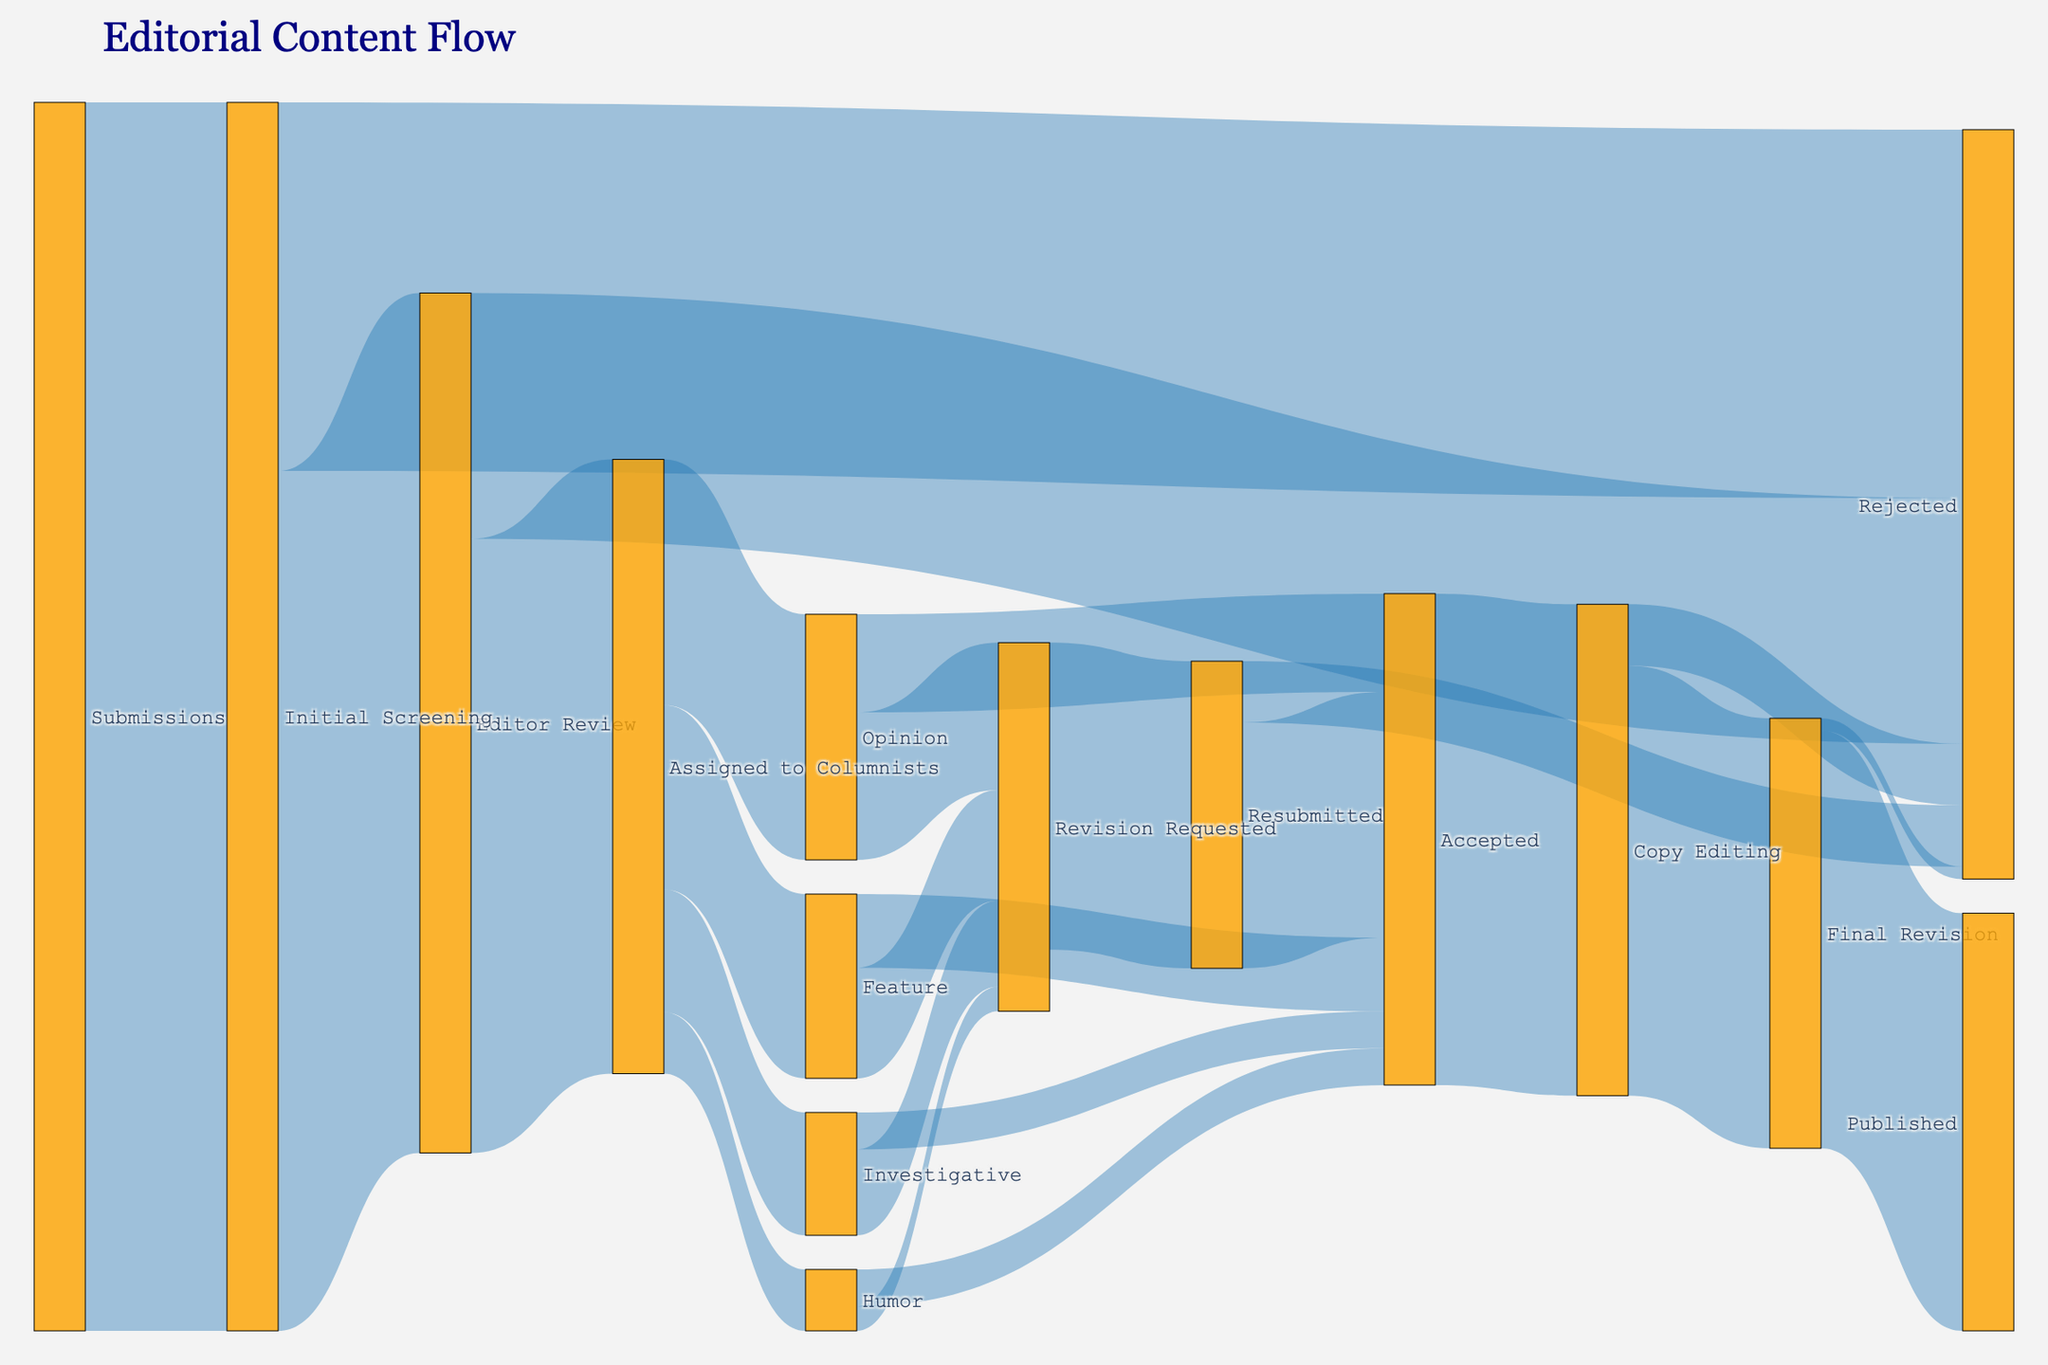What is the total number of submissions at the starting point? The total number of submissions is indicated by the flow from "Submissions" to "Initial Screening" which is 1000.
Answer: 1000 How many submissions are rejected in the Initial Screening stage? The number of submissions rejected in the Initial Screening stage is shown by the flow from "Initial Screening" to "Rejected," which is 300.
Answer: 300 How many submissions proceed to the Editor Review stage? The number of submissions proceeding to the Editor Review stage is shown by the flow from "Initial Screening" to "Editor Review," which is 700.
Answer: 700 Of the submissions that proceed to the Editor Review, how many are assigned to columnists? The number of submissions assigned to columnists from the Editor Review stage is shown by the flow from "Editor Review" to "Assigned to Columnists," which is 500.
Answer: 500 What is the total number of submissions that eventually get published? To find the total number of submissions that get published, follow the flow from "Final Revision" to "Published," which is 340.
Answer: 340 How many submissions are there in the Opinion category that are eventually accepted? The number of submissions in the Opinion category that are eventually accepted is shown by the flow from "Opinion" to "Accepted," which is 80.
Answer: 80 What is the total number of submissions that undergo Revision Requested after being assigned to columnists? Sum the flows from "Opinion," "Feature," "Investigative," and "Humor" to "Revision Requested": 120 + 90 + 70 + 20 = 300.
Answer: 300 Among the submissions that were accepted, how many of them proceeded to Copy Editing? The flow from "Accepted" to "Copy Editing" shows how many accepted submissions proceeded to Copy Editing, which is 400.
Answer: 400 How many submissions are finally rejected during the Copy Editing stage? The number of submissions rejected during the Copy Editing stage is indicated by the flow from "Copy Editing" to "Rejected," which is 50.
Answer: 50 What proportion of the originally submitted articles are finally published? First, determine the total number of submissions initially (1000). Then, find the number of articles finally published (340). The proportion is 340 / 1000.
Answer: 34% 